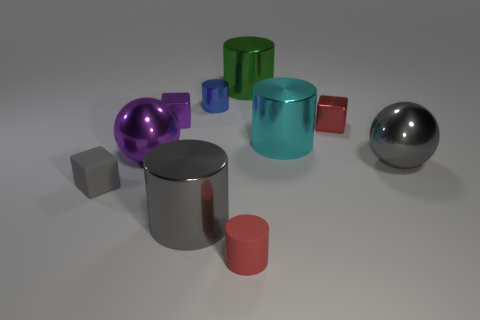Subtract all tiny metallic cubes. How many cubes are left? 1 Subtract all spheres. How many objects are left? 8 Subtract all gray spheres. How many spheres are left? 1 Subtract all cyan cubes. Subtract all blue balls. How many cubes are left? 3 Subtract all green cylinders. How many green spheres are left? 0 Subtract all tiny red matte cylinders. Subtract all small shiny cylinders. How many objects are left? 8 Add 9 tiny blue metallic things. How many tiny blue metallic things are left? 10 Add 6 large blue rubber balls. How many large blue rubber balls exist? 6 Subtract 1 blue cylinders. How many objects are left? 9 Subtract 3 cylinders. How many cylinders are left? 2 